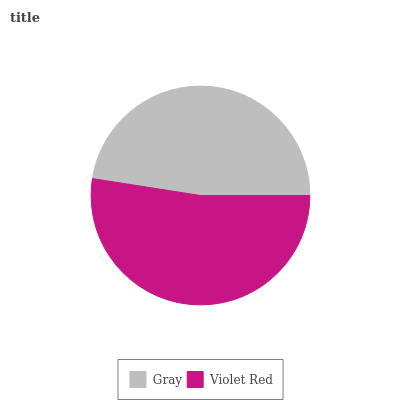Is Gray the minimum?
Answer yes or no. Yes. Is Violet Red the maximum?
Answer yes or no. Yes. Is Violet Red the minimum?
Answer yes or no. No. Is Violet Red greater than Gray?
Answer yes or no. Yes. Is Gray less than Violet Red?
Answer yes or no. Yes. Is Gray greater than Violet Red?
Answer yes or no. No. Is Violet Red less than Gray?
Answer yes or no. No. Is Violet Red the high median?
Answer yes or no. Yes. Is Gray the low median?
Answer yes or no. Yes. Is Gray the high median?
Answer yes or no. No. Is Violet Red the low median?
Answer yes or no. No. 